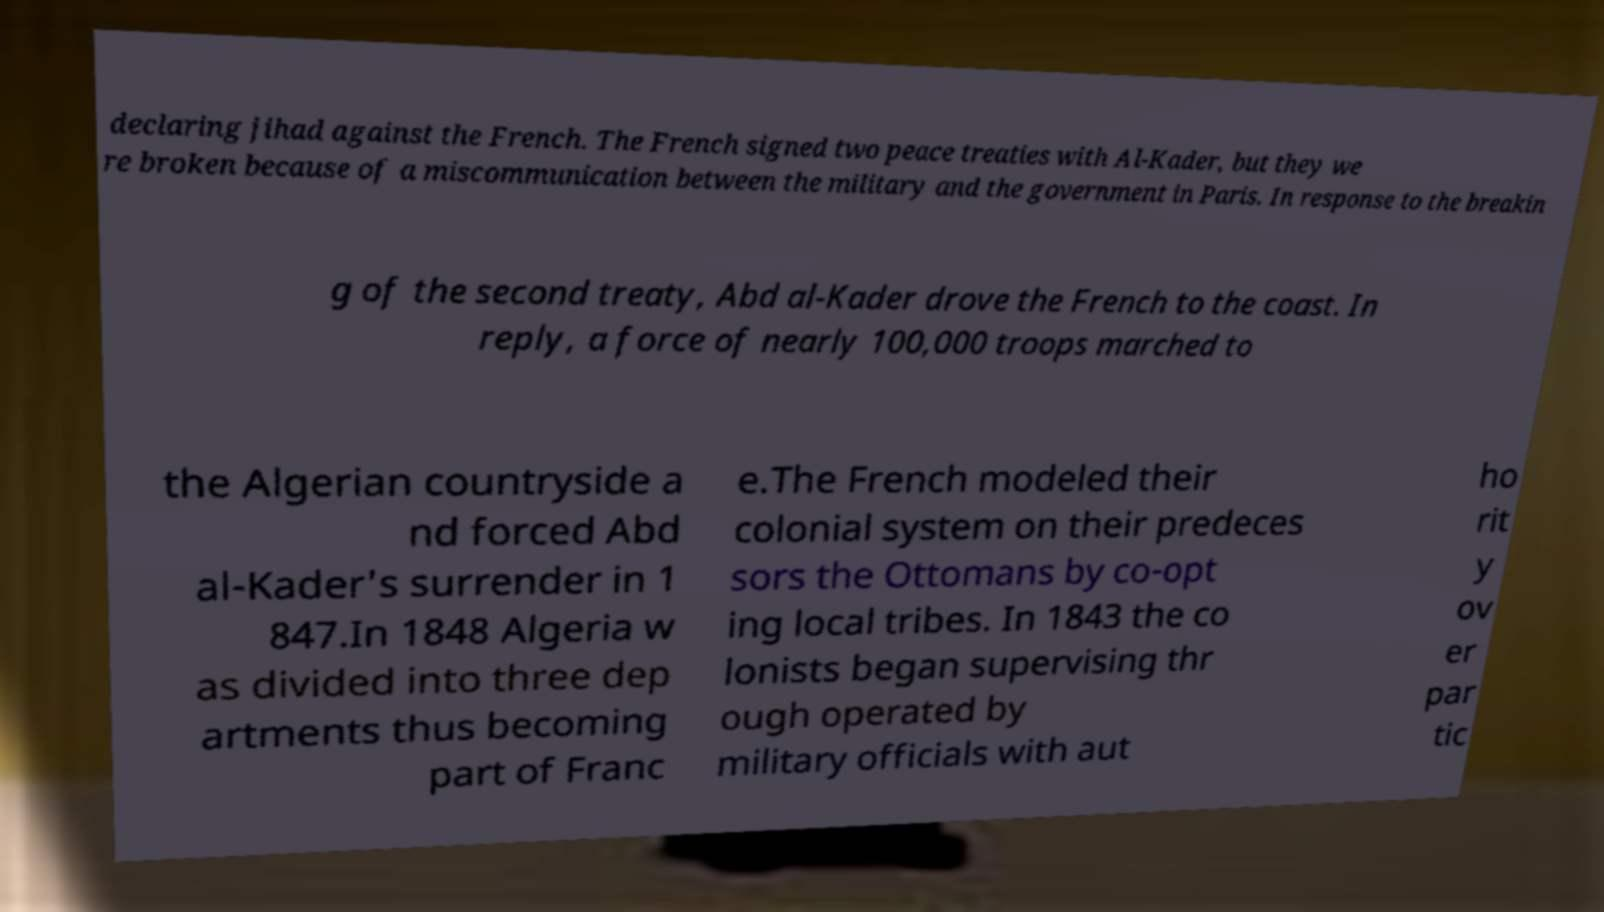For documentation purposes, I need the text within this image transcribed. Could you provide that? declaring jihad against the French. The French signed two peace treaties with Al-Kader, but they we re broken because of a miscommunication between the military and the government in Paris. In response to the breakin g of the second treaty, Abd al-Kader drove the French to the coast. In reply, a force of nearly 100,000 troops marched to the Algerian countryside a nd forced Abd al-Kader's surrender in 1 847.In 1848 Algeria w as divided into three dep artments thus becoming part of Franc e.The French modeled their colonial system on their predeces sors the Ottomans by co-opt ing local tribes. In 1843 the co lonists began supervising thr ough operated by military officials with aut ho rit y ov er par tic 